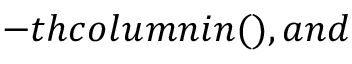<formula> <loc_0><loc_0><loc_500><loc_500>- t h c o l u m n i n ( ) , a n d</formula> 